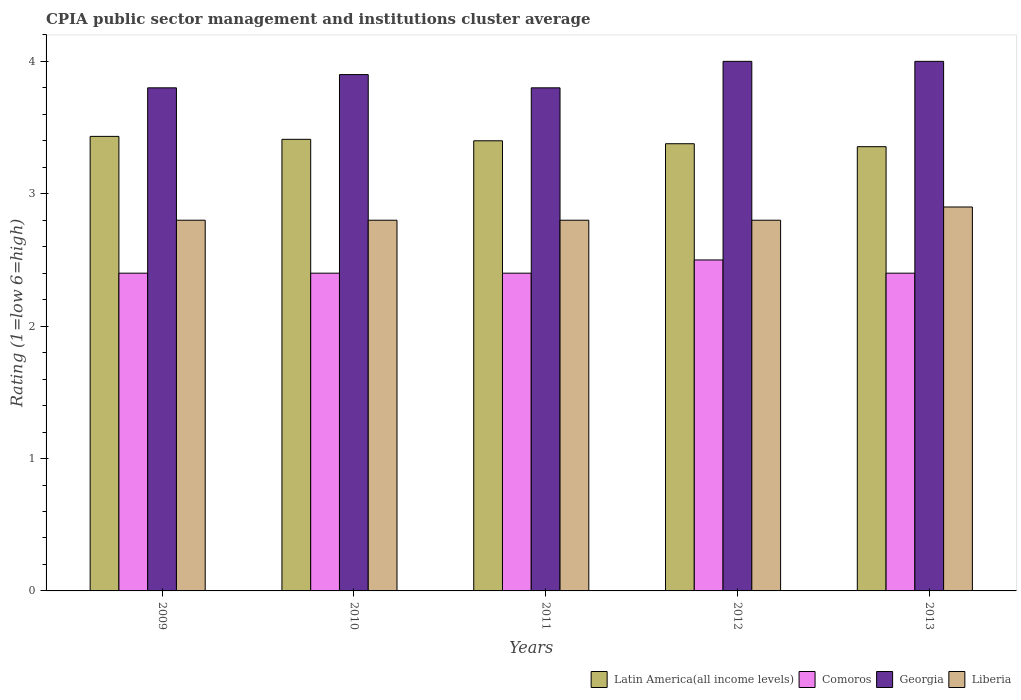How many different coloured bars are there?
Provide a short and direct response. 4. How many bars are there on the 3rd tick from the left?
Offer a terse response. 4. How many bars are there on the 4th tick from the right?
Make the answer very short. 4. What is the label of the 4th group of bars from the left?
Ensure brevity in your answer.  2012. Across all years, what is the maximum CPIA rating in Georgia?
Ensure brevity in your answer.  4. Across all years, what is the minimum CPIA rating in Comoros?
Your answer should be very brief. 2.4. In which year was the CPIA rating in Liberia minimum?
Provide a succinct answer. 2009. What is the difference between the CPIA rating in Comoros in 2010 and the CPIA rating in Liberia in 2012?
Give a very brief answer. -0.4. What is the average CPIA rating in Latin America(all income levels) per year?
Offer a terse response. 3.4. In the year 2009, what is the difference between the CPIA rating in Liberia and CPIA rating in Latin America(all income levels)?
Provide a succinct answer. -0.63. What is the ratio of the CPIA rating in Comoros in 2009 to that in 2011?
Keep it short and to the point. 1. What is the difference between the highest and the second highest CPIA rating in Liberia?
Ensure brevity in your answer.  0.1. What is the difference between the highest and the lowest CPIA rating in Comoros?
Ensure brevity in your answer.  0.1. What does the 2nd bar from the left in 2009 represents?
Your answer should be compact. Comoros. What does the 4th bar from the right in 2012 represents?
Provide a short and direct response. Latin America(all income levels). What is the difference between two consecutive major ticks on the Y-axis?
Provide a succinct answer. 1. Are the values on the major ticks of Y-axis written in scientific E-notation?
Keep it short and to the point. No. Where does the legend appear in the graph?
Provide a short and direct response. Bottom right. How many legend labels are there?
Provide a short and direct response. 4. How are the legend labels stacked?
Provide a short and direct response. Horizontal. What is the title of the graph?
Offer a very short reply. CPIA public sector management and institutions cluster average. What is the label or title of the X-axis?
Ensure brevity in your answer.  Years. What is the label or title of the Y-axis?
Provide a short and direct response. Rating (1=low 6=high). What is the Rating (1=low 6=high) in Latin America(all income levels) in 2009?
Ensure brevity in your answer.  3.43. What is the Rating (1=low 6=high) in Comoros in 2009?
Provide a short and direct response. 2.4. What is the Rating (1=low 6=high) of Liberia in 2009?
Keep it short and to the point. 2.8. What is the Rating (1=low 6=high) of Latin America(all income levels) in 2010?
Offer a very short reply. 3.41. What is the Rating (1=low 6=high) of Liberia in 2010?
Your answer should be compact. 2.8. What is the Rating (1=low 6=high) in Comoros in 2011?
Offer a very short reply. 2.4. What is the Rating (1=low 6=high) of Liberia in 2011?
Your response must be concise. 2.8. What is the Rating (1=low 6=high) of Latin America(all income levels) in 2012?
Your answer should be very brief. 3.38. What is the Rating (1=low 6=high) in Latin America(all income levels) in 2013?
Ensure brevity in your answer.  3.36. Across all years, what is the maximum Rating (1=low 6=high) of Latin America(all income levels)?
Keep it short and to the point. 3.43. Across all years, what is the maximum Rating (1=low 6=high) of Comoros?
Keep it short and to the point. 2.5. Across all years, what is the maximum Rating (1=low 6=high) of Liberia?
Your response must be concise. 2.9. Across all years, what is the minimum Rating (1=low 6=high) of Latin America(all income levels)?
Your response must be concise. 3.36. Across all years, what is the minimum Rating (1=low 6=high) of Comoros?
Keep it short and to the point. 2.4. Across all years, what is the minimum Rating (1=low 6=high) of Georgia?
Provide a succinct answer. 3.8. What is the total Rating (1=low 6=high) in Latin America(all income levels) in the graph?
Offer a terse response. 16.98. What is the total Rating (1=low 6=high) in Comoros in the graph?
Provide a short and direct response. 12.1. What is the difference between the Rating (1=low 6=high) in Latin America(all income levels) in 2009 and that in 2010?
Your response must be concise. 0.02. What is the difference between the Rating (1=low 6=high) in Liberia in 2009 and that in 2010?
Keep it short and to the point. 0. What is the difference between the Rating (1=low 6=high) of Latin America(all income levels) in 2009 and that in 2011?
Ensure brevity in your answer.  0.03. What is the difference between the Rating (1=low 6=high) of Georgia in 2009 and that in 2011?
Your answer should be very brief. 0. What is the difference between the Rating (1=low 6=high) in Liberia in 2009 and that in 2011?
Make the answer very short. 0. What is the difference between the Rating (1=low 6=high) in Latin America(all income levels) in 2009 and that in 2012?
Your answer should be compact. 0.06. What is the difference between the Rating (1=low 6=high) of Georgia in 2009 and that in 2012?
Offer a very short reply. -0.2. What is the difference between the Rating (1=low 6=high) in Latin America(all income levels) in 2009 and that in 2013?
Ensure brevity in your answer.  0.08. What is the difference between the Rating (1=low 6=high) of Latin America(all income levels) in 2010 and that in 2011?
Keep it short and to the point. 0.01. What is the difference between the Rating (1=low 6=high) of Georgia in 2010 and that in 2011?
Offer a very short reply. 0.1. What is the difference between the Rating (1=low 6=high) in Comoros in 2010 and that in 2012?
Offer a very short reply. -0.1. What is the difference between the Rating (1=low 6=high) of Liberia in 2010 and that in 2012?
Offer a terse response. 0. What is the difference between the Rating (1=low 6=high) in Latin America(all income levels) in 2010 and that in 2013?
Make the answer very short. 0.06. What is the difference between the Rating (1=low 6=high) of Comoros in 2010 and that in 2013?
Offer a terse response. 0. What is the difference between the Rating (1=low 6=high) in Georgia in 2010 and that in 2013?
Provide a short and direct response. -0.1. What is the difference between the Rating (1=low 6=high) in Latin America(all income levels) in 2011 and that in 2012?
Provide a succinct answer. 0.02. What is the difference between the Rating (1=low 6=high) in Georgia in 2011 and that in 2012?
Offer a very short reply. -0.2. What is the difference between the Rating (1=low 6=high) of Liberia in 2011 and that in 2012?
Give a very brief answer. 0. What is the difference between the Rating (1=low 6=high) in Latin America(all income levels) in 2011 and that in 2013?
Ensure brevity in your answer.  0.04. What is the difference between the Rating (1=low 6=high) of Georgia in 2011 and that in 2013?
Make the answer very short. -0.2. What is the difference between the Rating (1=low 6=high) in Latin America(all income levels) in 2012 and that in 2013?
Give a very brief answer. 0.02. What is the difference between the Rating (1=low 6=high) of Comoros in 2012 and that in 2013?
Ensure brevity in your answer.  0.1. What is the difference between the Rating (1=low 6=high) in Georgia in 2012 and that in 2013?
Your answer should be compact. 0. What is the difference between the Rating (1=low 6=high) of Liberia in 2012 and that in 2013?
Provide a short and direct response. -0.1. What is the difference between the Rating (1=low 6=high) of Latin America(all income levels) in 2009 and the Rating (1=low 6=high) of Georgia in 2010?
Your response must be concise. -0.47. What is the difference between the Rating (1=low 6=high) of Latin America(all income levels) in 2009 and the Rating (1=low 6=high) of Liberia in 2010?
Ensure brevity in your answer.  0.63. What is the difference between the Rating (1=low 6=high) of Comoros in 2009 and the Rating (1=low 6=high) of Liberia in 2010?
Ensure brevity in your answer.  -0.4. What is the difference between the Rating (1=low 6=high) in Georgia in 2009 and the Rating (1=low 6=high) in Liberia in 2010?
Ensure brevity in your answer.  1. What is the difference between the Rating (1=low 6=high) in Latin America(all income levels) in 2009 and the Rating (1=low 6=high) in Comoros in 2011?
Offer a terse response. 1.03. What is the difference between the Rating (1=low 6=high) in Latin America(all income levels) in 2009 and the Rating (1=low 6=high) in Georgia in 2011?
Make the answer very short. -0.37. What is the difference between the Rating (1=low 6=high) of Latin America(all income levels) in 2009 and the Rating (1=low 6=high) of Liberia in 2011?
Your answer should be compact. 0.63. What is the difference between the Rating (1=low 6=high) of Comoros in 2009 and the Rating (1=low 6=high) of Georgia in 2011?
Ensure brevity in your answer.  -1.4. What is the difference between the Rating (1=low 6=high) in Georgia in 2009 and the Rating (1=low 6=high) in Liberia in 2011?
Your answer should be compact. 1. What is the difference between the Rating (1=low 6=high) in Latin America(all income levels) in 2009 and the Rating (1=low 6=high) in Georgia in 2012?
Ensure brevity in your answer.  -0.57. What is the difference between the Rating (1=low 6=high) of Latin America(all income levels) in 2009 and the Rating (1=low 6=high) of Liberia in 2012?
Provide a succinct answer. 0.63. What is the difference between the Rating (1=low 6=high) of Comoros in 2009 and the Rating (1=low 6=high) of Georgia in 2012?
Your answer should be very brief. -1.6. What is the difference between the Rating (1=low 6=high) in Latin America(all income levels) in 2009 and the Rating (1=low 6=high) in Comoros in 2013?
Offer a terse response. 1.03. What is the difference between the Rating (1=low 6=high) of Latin America(all income levels) in 2009 and the Rating (1=low 6=high) of Georgia in 2013?
Your answer should be very brief. -0.57. What is the difference between the Rating (1=low 6=high) in Latin America(all income levels) in 2009 and the Rating (1=low 6=high) in Liberia in 2013?
Ensure brevity in your answer.  0.53. What is the difference between the Rating (1=low 6=high) in Comoros in 2009 and the Rating (1=low 6=high) in Georgia in 2013?
Make the answer very short. -1.6. What is the difference between the Rating (1=low 6=high) of Latin America(all income levels) in 2010 and the Rating (1=low 6=high) of Comoros in 2011?
Make the answer very short. 1.01. What is the difference between the Rating (1=low 6=high) of Latin America(all income levels) in 2010 and the Rating (1=low 6=high) of Georgia in 2011?
Offer a terse response. -0.39. What is the difference between the Rating (1=low 6=high) of Latin America(all income levels) in 2010 and the Rating (1=low 6=high) of Liberia in 2011?
Your answer should be compact. 0.61. What is the difference between the Rating (1=low 6=high) of Comoros in 2010 and the Rating (1=low 6=high) of Georgia in 2011?
Your answer should be very brief. -1.4. What is the difference between the Rating (1=low 6=high) of Comoros in 2010 and the Rating (1=low 6=high) of Liberia in 2011?
Make the answer very short. -0.4. What is the difference between the Rating (1=low 6=high) in Latin America(all income levels) in 2010 and the Rating (1=low 6=high) in Comoros in 2012?
Make the answer very short. 0.91. What is the difference between the Rating (1=low 6=high) in Latin America(all income levels) in 2010 and the Rating (1=low 6=high) in Georgia in 2012?
Make the answer very short. -0.59. What is the difference between the Rating (1=low 6=high) in Latin America(all income levels) in 2010 and the Rating (1=low 6=high) in Liberia in 2012?
Keep it short and to the point. 0.61. What is the difference between the Rating (1=low 6=high) of Comoros in 2010 and the Rating (1=low 6=high) of Georgia in 2012?
Ensure brevity in your answer.  -1.6. What is the difference between the Rating (1=low 6=high) of Latin America(all income levels) in 2010 and the Rating (1=low 6=high) of Comoros in 2013?
Your answer should be compact. 1.01. What is the difference between the Rating (1=low 6=high) of Latin America(all income levels) in 2010 and the Rating (1=low 6=high) of Georgia in 2013?
Make the answer very short. -0.59. What is the difference between the Rating (1=low 6=high) in Latin America(all income levels) in 2010 and the Rating (1=low 6=high) in Liberia in 2013?
Ensure brevity in your answer.  0.51. What is the difference between the Rating (1=low 6=high) in Comoros in 2010 and the Rating (1=low 6=high) in Georgia in 2013?
Keep it short and to the point. -1.6. What is the difference between the Rating (1=low 6=high) in Comoros in 2010 and the Rating (1=low 6=high) in Liberia in 2013?
Your answer should be compact. -0.5. What is the difference between the Rating (1=low 6=high) of Georgia in 2010 and the Rating (1=low 6=high) of Liberia in 2013?
Provide a short and direct response. 1. What is the difference between the Rating (1=low 6=high) of Latin America(all income levels) in 2011 and the Rating (1=low 6=high) of Liberia in 2012?
Provide a short and direct response. 0.6. What is the difference between the Rating (1=low 6=high) of Latin America(all income levels) in 2011 and the Rating (1=low 6=high) of Comoros in 2013?
Make the answer very short. 1. What is the difference between the Rating (1=low 6=high) of Latin America(all income levels) in 2011 and the Rating (1=low 6=high) of Liberia in 2013?
Your response must be concise. 0.5. What is the difference between the Rating (1=low 6=high) in Comoros in 2011 and the Rating (1=low 6=high) in Liberia in 2013?
Offer a terse response. -0.5. What is the difference between the Rating (1=low 6=high) of Georgia in 2011 and the Rating (1=low 6=high) of Liberia in 2013?
Keep it short and to the point. 0.9. What is the difference between the Rating (1=low 6=high) of Latin America(all income levels) in 2012 and the Rating (1=low 6=high) of Comoros in 2013?
Provide a succinct answer. 0.98. What is the difference between the Rating (1=low 6=high) of Latin America(all income levels) in 2012 and the Rating (1=low 6=high) of Georgia in 2013?
Provide a short and direct response. -0.62. What is the difference between the Rating (1=low 6=high) in Latin America(all income levels) in 2012 and the Rating (1=low 6=high) in Liberia in 2013?
Keep it short and to the point. 0.48. What is the difference between the Rating (1=low 6=high) in Comoros in 2012 and the Rating (1=low 6=high) in Georgia in 2013?
Your response must be concise. -1.5. What is the average Rating (1=low 6=high) in Latin America(all income levels) per year?
Offer a very short reply. 3.4. What is the average Rating (1=low 6=high) in Comoros per year?
Provide a succinct answer. 2.42. What is the average Rating (1=low 6=high) in Georgia per year?
Ensure brevity in your answer.  3.9. What is the average Rating (1=low 6=high) of Liberia per year?
Keep it short and to the point. 2.82. In the year 2009, what is the difference between the Rating (1=low 6=high) of Latin America(all income levels) and Rating (1=low 6=high) of Comoros?
Ensure brevity in your answer.  1.03. In the year 2009, what is the difference between the Rating (1=low 6=high) of Latin America(all income levels) and Rating (1=low 6=high) of Georgia?
Keep it short and to the point. -0.37. In the year 2009, what is the difference between the Rating (1=low 6=high) of Latin America(all income levels) and Rating (1=low 6=high) of Liberia?
Your answer should be compact. 0.63. In the year 2009, what is the difference between the Rating (1=low 6=high) in Comoros and Rating (1=low 6=high) in Georgia?
Provide a short and direct response. -1.4. In the year 2009, what is the difference between the Rating (1=low 6=high) in Comoros and Rating (1=low 6=high) in Liberia?
Offer a terse response. -0.4. In the year 2009, what is the difference between the Rating (1=low 6=high) of Georgia and Rating (1=low 6=high) of Liberia?
Provide a short and direct response. 1. In the year 2010, what is the difference between the Rating (1=low 6=high) in Latin America(all income levels) and Rating (1=low 6=high) in Comoros?
Your answer should be very brief. 1.01. In the year 2010, what is the difference between the Rating (1=low 6=high) of Latin America(all income levels) and Rating (1=low 6=high) of Georgia?
Ensure brevity in your answer.  -0.49. In the year 2010, what is the difference between the Rating (1=low 6=high) of Latin America(all income levels) and Rating (1=low 6=high) of Liberia?
Give a very brief answer. 0.61. In the year 2010, what is the difference between the Rating (1=low 6=high) of Comoros and Rating (1=low 6=high) of Georgia?
Your answer should be compact. -1.5. In the year 2010, what is the difference between the Rating (1=low 6=high) in Comoros and Rating (1=low 6=high) in Liberia?
Keep it short and to the point. -0.4. In the year 2010, what is the difference between the Rating (1=low 6=high) of Georgia and Rating (1=low 6=high) of Liberia?
Your answer should be compact. 1.1. In the year 2011, what is the difference between the Rating (1=low 6=high) of Latin America(all income levels) and Rating (1=low 6=high) of Liberia?
Keep it short and to the point. 0.6. In the year 2011, what is the difference between the Rating (1=low 6=high) in Comoros and Rating (1=low 6=high) in Georgia?
Keep it short and to the point. -1.4. In the year 2011, what is the difference between the Rating (1=low 6=high) in Comoros and Rating (1=low 6=high) in Liberia?
Your answer should be compact. -0.4. In the year 2011, what is the difference between the Rating (1=low 6=high) of Georgia and Rating (1=low 6=high) of Liberia?
Offer a terse response. 1. In the year 2012, what is the difference between the Rating (1=low 6=high) in Latin America(all income levels) and Rating (1=low 6=high) in Comoros?
Keep it short and to the point. 0.88. In the year 2012, what is the difference between the Rating (1=low 6=high) in Latin America(all income levels) and Rating (1=low 6=high) in Georgia?
Ensure brevity in your answer.  -0.62. In the year 2012, what is the difference between the Rating (1=low 6=high) of Latin America(all income levels) and Rating (1=low 6=high) of Liberia?
Provide a succinct answer. 0.58. In the year 2012, what is the difference between the Rating (1=low 6=high) of Georgia and Rating (1=low 6=high) of Liberia?
Offer a very short reply. 1.2. In the year 2013, what is the difference between the Rating (1=low 6=high) in Latin America(all income levels) and Rating (1=low 6=high) in Comoros?
Offer a very short reply. 0.96. In the year 2013, what is the difference between the Rating (1=low 6=high) in Latin America(all income levels) and Rating (1=low 6=high) in Georgia?
Ensure brevity in your answer.  -0.64. In the year 2013, what is the difference between the Rating (1=low 6=high) of Latin America(all income levels) and Rating (1=low 6=high) of Liberia?
Ensure brevity in your answer.  0.46. In the year 2013, what is the difference between the Rating (1=low 6=high) of Comoros and Rating (1=low 6=high) of Georgia?
Your answer should be compact. -1.6. In the year 2013, what is the difference between the Rating (1=low 6=high) of Georgia and Rating (1=low 6=high) of Liberia?
Keep it short and to the point. 1.1. What is the ratio of the Rating (1=low 6=high) of Latin America(all income levels) in 2009 to that in 2010?
Offer a very short reply. 1.01. What is the ratio of the Rating (1=low 6=high) of Georgia in 2009 to that in 2010?
Make the answer very short. 0.97. What is the ratio of the Rating (1=low 6=high) in Latin America(all income levels) in 2009 to that in 2011?
Give a very brief answer. 1.01. What is the ratio of the Rating (1=low 6=high) in Comoros in 2009 to that in 2011?
Your response must be concise. 1. What is the ratio of the Rating (1=low 6=high) of Georgia in 2009 to that in 2011?
Make the answer very short. 1. What is the ratio of the Rating (1=low 6=high) in Liberia in 2009 to that in 2011?
Ensure brevity in your answer.  1. What is the ratio of the Rating (1=low 6=high) in Latin America(all income levels) in 2009 to that in 2012?
Give a very brief answer. 1.02. What is the ratio of the Rating (1=low 6=high) of Comoros in 2009 to that in 2012?
Provide a succinct answer. 0.96. What is the ratio of the Rating (1=low 6=high) of Liberia in 2009 to that in 2012?
Offer a terse response. 1. What is the ratio of the Rating (1=low 6=high) of Latin America(all income levels) in 2009 to that in 2013?
Keep it short and to the point. 1.02. What is the ratio of the Rating (1=low 6=high) in Georgia in 2009 to that in 2013?
Give a very brief answer. 0.95. What is the ratio of the Rating (1=low 6=high) in Liberia in 2009 to that in 2013?
Offer a very short reply. 0.97. What is the ratio of the Rating (1=low 6=high) of Georgia in 2010 to that in 2011?
Keep it short and to the point. 1.03. What is the ratio of the Rating (1=low 6=high) in Latin America(all income levels) in 2010 to that in 2012?
Your answer should be compact. 1.01. What is the ratio of the Rating (1=low 6=high) of Liberia in 2010 to that in 2012?
Provide a short and direct response. 1. What is the ratio of the Rating (1=low 6=high) in Latin America(all income levels) in 2010 to that in 2013?
Provide a short and direct response. 1.02. What is the ratio of the Rating (1=low 6=high) in Liberia in 2010 to that in 2013?
Provide a succinct answer. 0.97. What is the ratio of the Rating (1=low 6=high) in Latin America(all income levels) in 2011 to that in 2012?
Provide a succinct answer. 1.01. What is the ratio of the Rating (1=low 6=high) in Liberia in 2011 to that in 2012?
Give a very brief answer. 1. What is the ratio of the Rating (1=low 6=high) in Latin America(all income levels) in 2011 to that in 2013?
Keep it short and to the point. 1.01. What is the ratio of the Rating (1=low 6=high) of Liberia in 2011 to that in 2013?
Keep it short and to the point. 0.97. What is the ratio of the Rating (1=low 6=high) in Latin America(all income levels) in 2012 to that in 2013?
Your answer should be compact. 1.01. What is the ratio of the Rating (1=low 6=high) of Comoros in 2012 to that in 2013?
Your response must be concise. 1.04. What is the ratio of the Rating (1=low 6=high) in Georgia in 2012 to that in 2013?
Offer a very short reply. 1. What is the ratio of the Rating (1=low 6=high) in Liberia in 2012 to that in 2013?
Provide a succinct answer. 0.97. What is the difference between the highest and the second highest Rating (1=low 6=high) in Latin America(all income levels)?
Provide a short and direct response. 0.02. What is the difference between the highest and the lowest Rating (1=low 6=high) in Latin America(all income levels)?
Keep it short and to the point. 0.08. What is the difference between the highest and the lowest Rating (1=low 6=high) in Georgia?
Make the answer very short. 0.2. What is the difference between the highest and the lowest Rating (1=low 6=high) in Liberia?
Give a very brief answer. 0.1. 